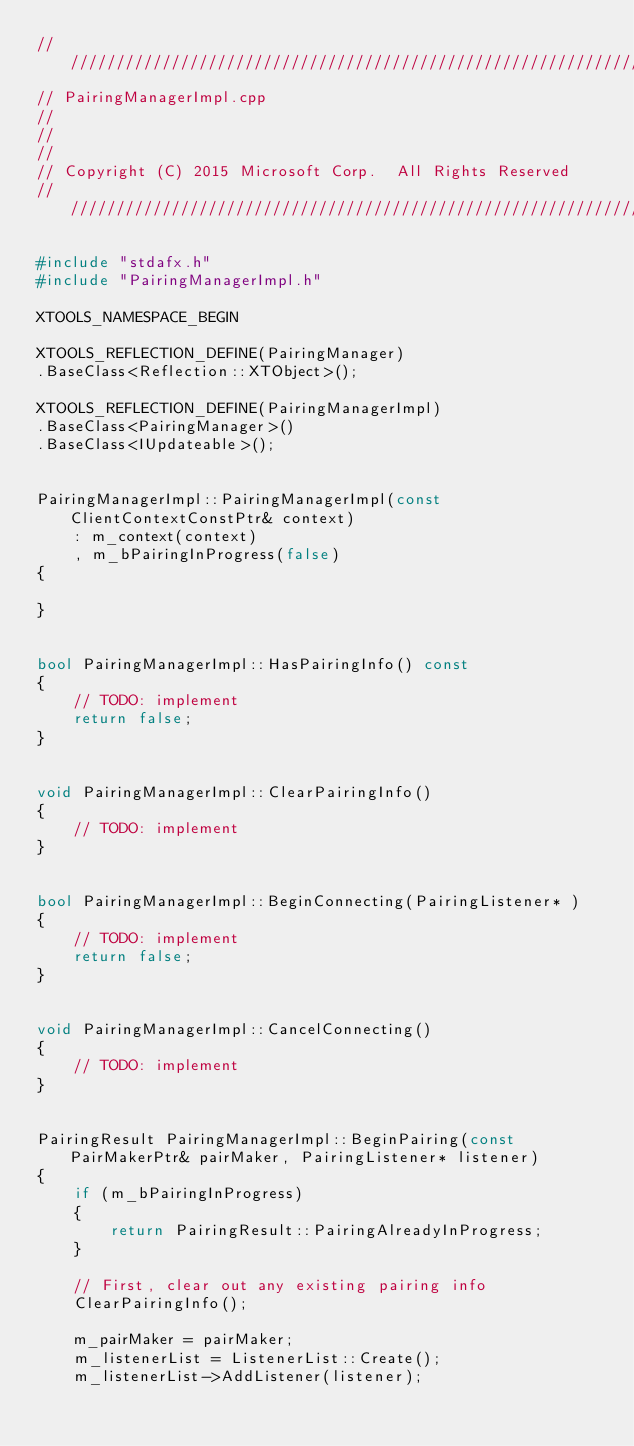Convert code to text. <code><loc_0><loc_0><loc_500><loc_500><_C++_>//////////////////////////////////////////////////////////////////////////
// PairingManagerImpl.cpp
//
// 
//
// Copyright (C) 2015 Microsoft Corp.  All Rights Reserved
//////////////////////////////////////////////////////////////////////////

#include "stdafx.h"
#include "PairingManagerImpl.h"

XTOOLS_NAMESPACE_BEGIN

XTOOLS_REFLECTION_DEFINE(PairingManager)
.BaseClass<Reflection::XTObject>();

XTOOLS_REFLECTION_DEFINE(PairingManagerImpl)
.BaseClass<PairingManager>()
.BaseClass<IUpdateable>();


PairingManagerImpl::PairingManagerImpl(const ClientContextConstPtr& context)
	: m_context(context)
	, m_bPairingInProgress(false)
{

}


bool PairingManagerImpl::HasPairingInfo() const
{
	// TODO: implement
	return false;
}


void PairingManagerImpl::ClearPairingInfo()
{
	// TODO: implement
}


bool PairingManagerImpl::BeginConnecting(PairingListener* )
{
	// TODO: implement
	return false;
}


void PairingManagerImpl::CancelConnecting()
{
	// TODO: implement
}


PairingResult PairingManagerImpl::BeginPairing(const PairMakerPtr& pairMaker, PairingListener* listener)
{
	if (m_bPairingInProgress)
	{
		return PairingResult::PairingAlreadyInProgress;
	}

	// First, clear out any existing pairing info
	ClearPairingInfo();

	m_pairMaker = pairMaker;
	m_listenerList = ListenerList::Create();
	m_listenerList->AddListener(listener);
</code> 